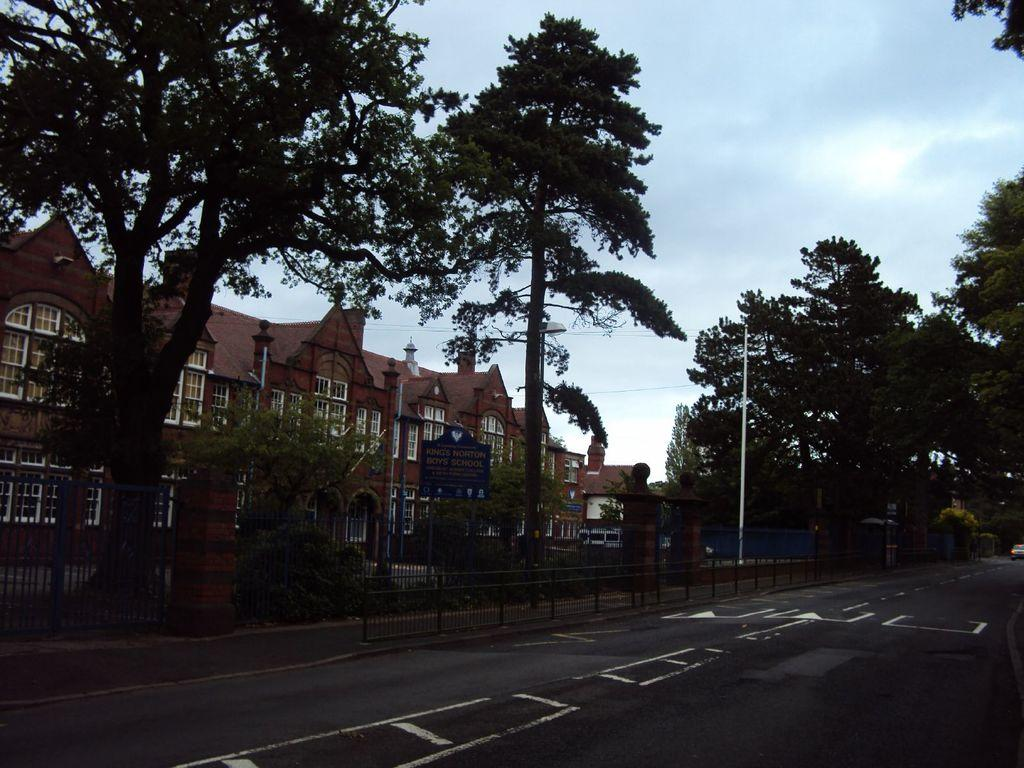What type of man-made structure can be seen in the image? There are buildings in the image. What is the primary surface visible in the image? There is a road in the image. What type of natural vegetation is present in the image? There are trees in the image. What is visible above the buildings and trees in the image? The sky is visible in the image. What can be observed in the sky in the image? Clouds are present in the sky. How many rabbits can be seen playing on the property in the image? There are no rabbits or property present in the image. What type of body is visible in the image? There is no body present in the image; it features a road, buildings, trees, and the sky. 